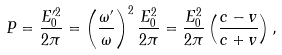<formula> <loc_0><loc_0><loc_500><loc_500>P = \frac { E _ { 0 } ^ { \prime 2 } } { 2 \pi } = \left ( \frac { \omega ^ { \prime } } { \omega } \right ) ^ { 2 } \frac { E _ { 0 } ^ { 2 } } { 2 \pi } = \frac { E _ { 0 } ^ { 2 } } { 2 \pi } \left ( \frac { c - v } { c + v } \right ) ,</formula> 